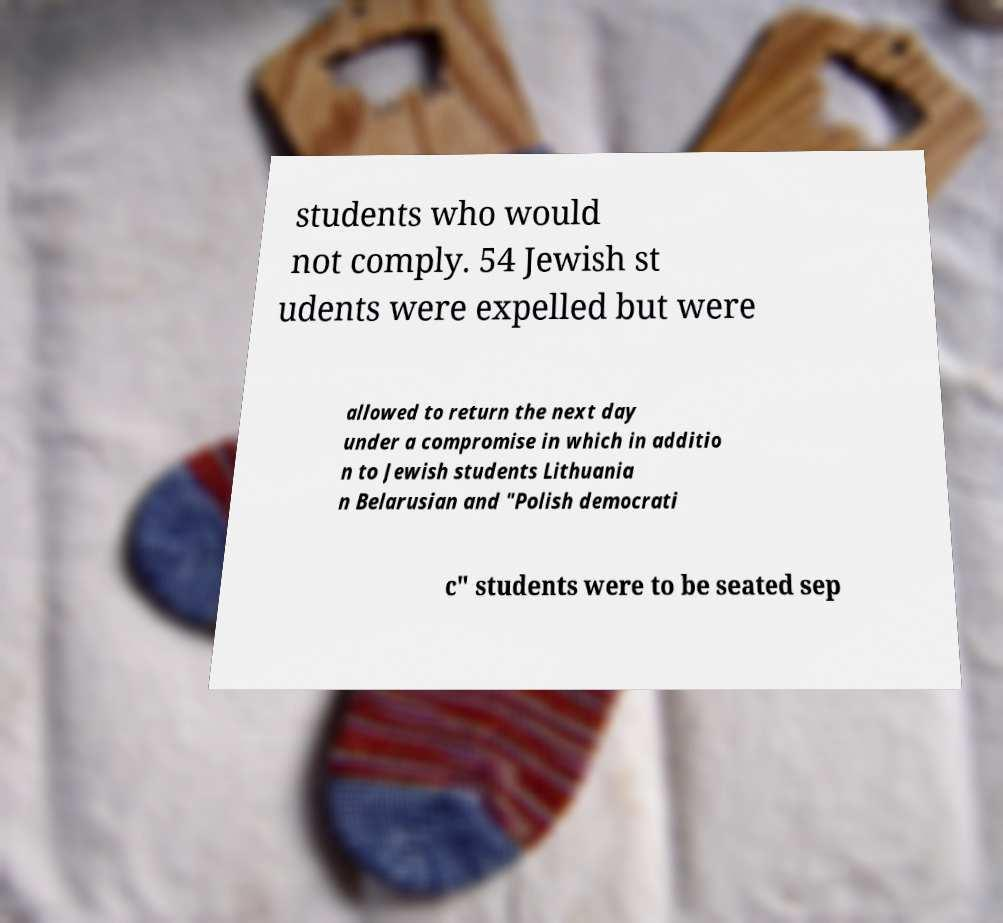For documentation purposes, I need the text within this image transcribed. Could you provide that? students who would not comply. 54 Jewish st udents were expelled but were allowed to return the next day under a compromise in which in additio n to Jewish students Lithuania n Belarusian and "Polish democrati c" students were to be seated sep 